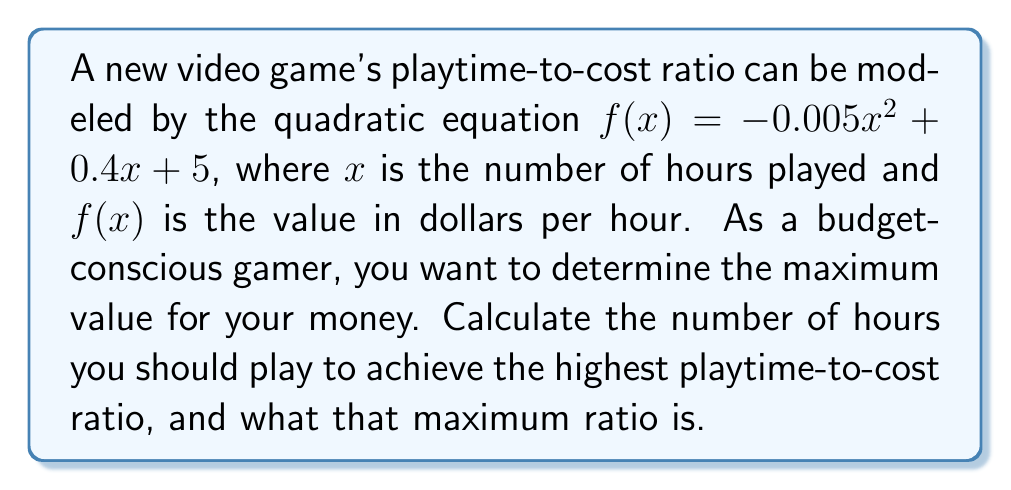What is the answer to this math problem? 1. The quadratic equation is in the form $f(x) = ax^2 + bx + c$, where:
   $a = -0.005$
   $b = 0.4$
   $c = 5$

2. For a quadratic function, the maximum or minimum occurs at the vertex. Since $a$ is negative, this parabola opens downward and has a maximum.

3. To find the x-coordinate of the vertex, use the formula: $x = -\frac{b}{2a}$

   $x = -\frac{0.4}{2(-0.005)} = -\frac{0.4}{-0.01} = 40$

4. The number of hours to achieve the highest ratio is 40 hours.

5. To find the maximum ratio, plug $x = 40$ into the original equation:

   $f(40) = -0.005(40)^2 + 0.4(40) + 5$
   $= -0.005(1600) + 16 + 5$
   $= -8 + 16 + 5$
   $= 13$

6. Therefore, the maximum playtime-to-cost ratio is $13 per hour.
Answer: 40 hours; $13/hour 